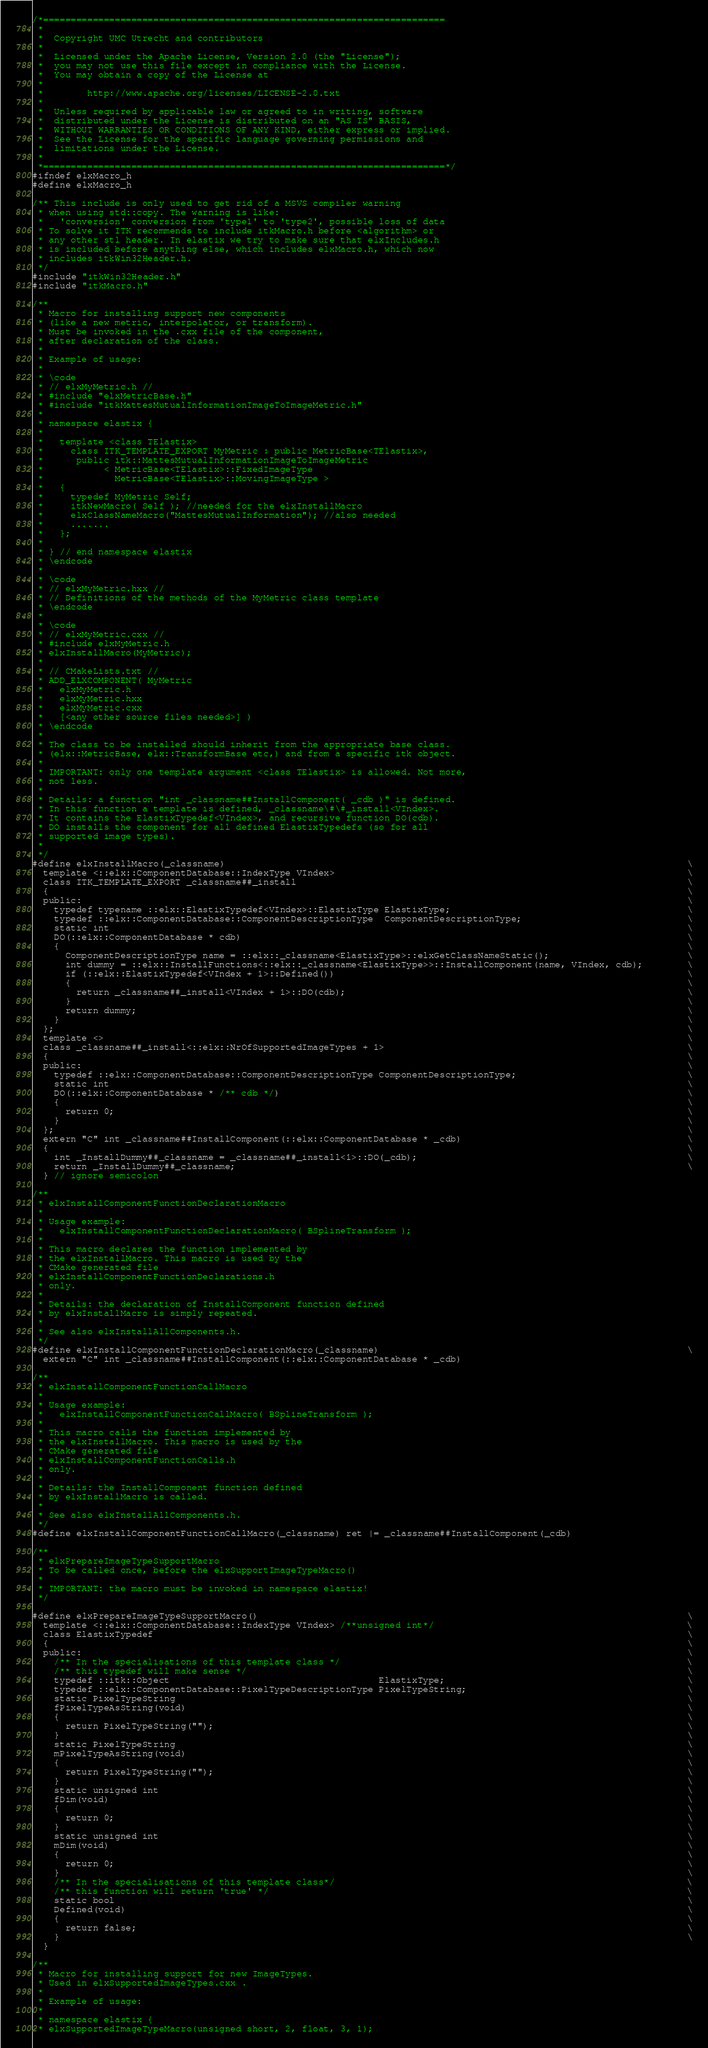<code> <loc_0><loc_0><loc_500><loc_500><_C_>/*=========================================================================
 *
 *  Copyright UMC Utrecht and contributors
 *
 *  Licensed under the Apache License, Version 2.0 (the "License");
 *  you may not use this file except in compliance with the License.
 *  You may obtain a copy of the License at
 *
 *        http://www.apache.org/licenses/LICENSE-2.0.txt
 *
 *  Unless required by applicable law or agreed to in writing, software
 *  distributed under the License is distributed on an "AS IS" BASIS,
 *  WITHOUT WARRANTIES OR CONDITIONS OF ANY KIND, either express or implied.
 *  See the License for the specific language governing permissions and
 *  limitations under the License.
 *
 *=========================================================================*/
#ifndef elxMacro_h
#define elxMacro_h

/** This include is only used to get rid of a MSVS compiler warning
 * when using std::copy. The warning is like:
 *   'conversion' conversion from 'type1' to 'type2', possible loss of data
 * To solve it ITK recommends to include itkMacro.h before <algorithm> or
 * any other stl header. In elastix we try to make sure that elxIncludes.h
 * is included before anything else, which includes elxMacro.h, which now
 * includes itkWin32Header.h.
 */
#include "itkWin32Header.h"
#include "itkMacro.h"

/**
 * Macro for installing support new components
 * (like a new metric, interpolator, or transform).
 * Must be invoked in the .cxx file of the component,
 * after declaration of the class.
 *
 * Example of usage:
 *
 * \code
 * // elxMyMetric.h //
 * #include "elxMetricBase.h"
 * #include "itkMattesMutualInformationImageToImageMetric.h"
 *
 * namespace elastix {
 *
 *   template <class TElastix>
 *     class ITK_TEMPLATE_EXPORT MyMetric : public MetricBase<TElastix>,
 *      public itk::MattesMutualInformationImageToImageMetric
 *           < MetricBase<TElastix>::FixedImageType
 *             MetricBase<TElastix>::MovingImageType >
 *   {
 *     typedef MyMetric Self;
 *     itkNewMacro( Self ); //needed for the elxInstallMacro
 *     elxClassNameMacro("MattesMutualInformation"); //also needed
 *     .......
 *   };
 *
 * } // end namespace elastix
 * \endcode
 *
 * \code
 * // elxMyMetric.hxx //
 * // Definitions of the methods of the MyMetric class template
 * \endcode
 *
 * \code
 * // elxMyMetric.cxx //
 * #include elxMyMetric.h
 * elxInstallMacro(MyMetric);
 *
 * // CMakeLists.txt //
 * ADD_ELXCOMPONENT( MyMetric
 *   elxMyMetric.h
 *   elxMyMetric.hxx
 *   elxMyMetric.cxx
 *   [<any other source files needed>] )
 * \endcode
 *
 * The class to be installed should inherit from the appropriate base class.
 * (elx::MetricBase, elx::TransformBase etc,) and from a specific itk object.
 *
 * IMPORTANT: only one template argument <class TElastix> is allowed. Not more,
 * not less.
 *
 * Details: a function "int _classname##InstallComponent( _cdb )" is defined.
 * In this function a template is defined, _classname\#\#_install<VIndex>.
 * It contains the ElastixTypedef<VIndex>, and recursive function DO(cdb).
 * DO installs the component for all defined ElastixTypedefs (so for all
 * supported image types).
 *
 */
#define elxInstallMacro(_classname)                                                                                    \
  template <::elx::ComponentDatabase::IndexType VIndex>                                                                \
  class ITK_TEMPLATE_EXPORT _classname##_install                                                                       \
  {                                                                                                                    \
  public:                                                                                                              \
    typedef typename ::elx::ElastixTypedef<VIndex>::ElastixType ElastixType;                                           \
    typedef ::elx::ComponentDatabase::ComponentDescriptionType  ComponentDescriptionType;                              \
    static int                                                                                                         \
    DO(::elx::ComponentDatabase * cdb)                                                                                 \
    {                                                                                                                  \
      ComponentDescriptionType name = ::elx::_classname<ElastixType>::elxGetClassNameStatic();                         \
      int dummy = ::elx::InstallFunctions<::elx::_classname<ElastixType>>::InstallComponent(name, VIndex, cdb);        \
      if (::elx::ElastixTypedef<VIndex + 1>::Defined())                                                                \
      {                                                                                                                \
        return _classname##_install<VIndex + 1>::DO(cdb);                                                              \
      }                                                                                                                \
      return dummy;                                                                                                    \
    }                                                                                                                  \
  };                                                                                                                   \
  template <>                                                                                                          \
  class _classname##_install<::elx::NrOfSupportedImageTypes + 1>                                                       \
  {                                                                                                                    \
  public:                                                                                                              \
    typedef ::elx::ComponentDatabase::ComponentDescriptionType ComponentDescriptionType;                               \
    static int                                                                                                         \
    DO(::elx::ComponentDatabase * /** cdb */)                                                                          \
    {                                                                                                                  \
      return 0;                                                                                                        \
    }                                                                                                                  \
  };                                                                                                                   \
  extern "C" int _classname##InstallComponent(::elx::ComponentDatabase * _cdb)                                         \
  {                                                                                                                    \
    int _InstallDummy##_classname = _classname##_install<1>::DO(_cdb);                                                 \
    return _InstallDummy##_classname;                                                                                  \
  } // ignore semicolon

/**
 * elxInstallComponentFunctionDeclarationMacro
 *
 * Usage example:
 *   elxInstallComponentFunctionDeclarationMacro( BSplineTransform );
 *
 * This macro declares the function implemented by
 * the elxInstallMacro. This macro is used by the
 * CMake generated file
 * elxInstallComponentFunctionDeclarations.h
 * only.
 *
 * Details: the declaration of InstallComponent function defined
 * by elxInstallMacro is simply repeated.
 *
 * See also elxInstallAllComponents.h.
 */
#define elxInstallComponentFunctionDeclarationMacro(_classname)                                                        \
  extern "C" int _classname##InstallComponent(::elx::ComponentDatabase * _cdb)

/**
 * elxInstallComponentFunctionCallMacro
 *
 * Usage example:
 *   elxInstallComponentFunctionCallMacro( BSplineTransform );
 *
 * This macro calls the function implemented by
 * the elxInstallMacro. This macro is used by the
 * CMake generated file
 * elxInstallComponentFunctionCalls.h
 * only.
 *
 * Details: the InstallComponent function defined
 * by elxInstallMacro is called.
 *
 * See also elxInstallAllComponents.h.
 */
#define elxInstallComponentFunctionCallMacro(_classname) ret |= _classname##InstallComponent(_cdb)

/**
 * elxPrepareImageTypeSupportMacro
 * To be called once, before the elxSupportImageTypeMacro()
 *
 * IMPORTANT: the macro must be invoked in namespace elastix!
 */

#define elxPrepareImageTypeSupportMacro()                                                                              \
  template <::elx::ComponentDatabase::IndexType VIndex> /**unsigned int*/                                              \
  class ElastixTypedef                                                                                                 \
  {                                                                                                                    \
  public:                                                                                                              \
    /** In the specialisations of this template class */                                                               \
    /** this typedef will make sense */                                                                                \
    typedef ::itk::Object                                      ElastixType;                                            \
    typedef ::elx::ComponentDatabase::PixelTypeDescriptionType PixelTypeString;                                        \
    static PixelTypeString                                                                                             \
    fPixelTypeAsString(void)                                                                                           \
    {                                                                                                                  \
      return PixelTypeString("");                                                                                      \
    }                                                                                                                  \
    static PixelTypeString                                                                                             \
    mPixelTypeAsString(void)                                                                                           \
    {                                                                                                                  \
      return PixelTypeString("");                                                                                      \
    }                                                                                                                  \
    static unsigned int                                                                                                \
    fDim(void)                                                                                                         \
    {                                                                                                                  \
      return 0;                                                                                                        \
    }                                                                                                                  \
    static unsigned int                                                                                                \
    mDim(void)                                                                                                         \
    {                                                                                                                  \
      return 0;                                                                                                        \
    }                                                                                                                  \
    /** In the specialisations of this template class*/                                                                \
    /** this function will return 'true' */                                                                            \
    static bool                                                                                                        \
    Defined(void)                                                                                                      \
    {                                                                                                                  \
      return false;                                                                                                    \
    }                                                                                                                  \
  }

/**
 * Macro for installing support for new ImageTypes.
 * Used in elxSupportedImageTypes.cxx .
 *
 * Example of usage:
 *
 * namespace elastix {
 * elxSupportedImageTypeMacro(unsigned short, 2, float, 3, 1);</code> 